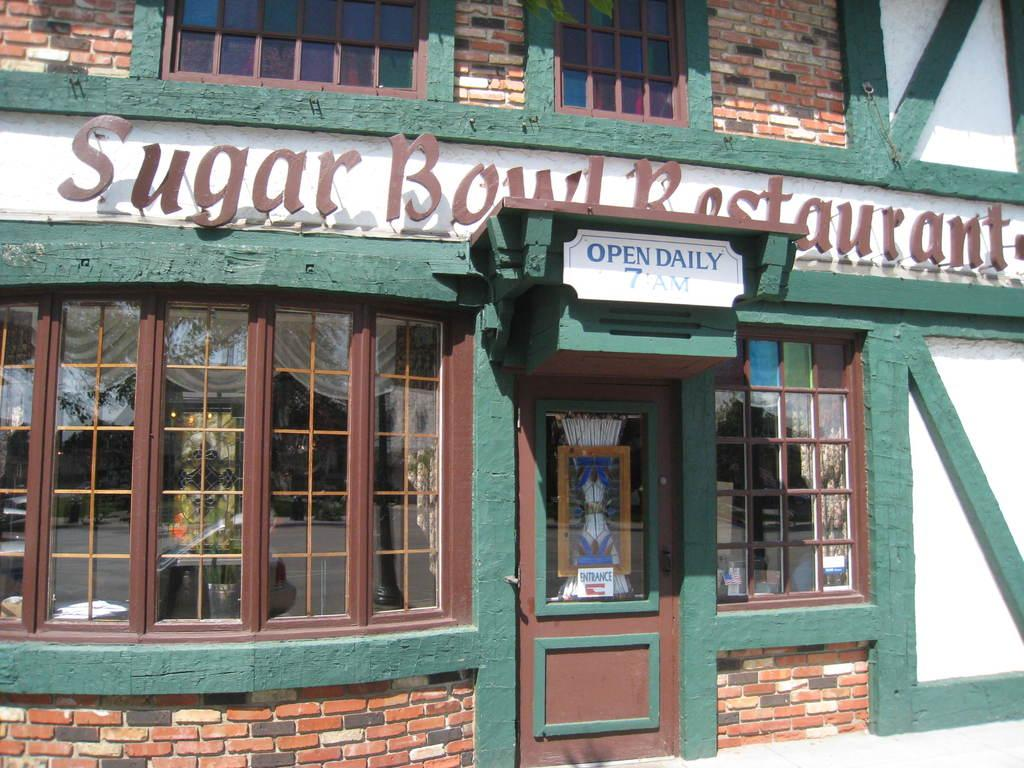What type of structure is visible in the image? There is a building in the image. What is one of the main features of the building? There is a door in the image. What type of material is used for the windows of the building? There are glass windows in the image. What is placed on the walls of the building? There are boards in the image. What can be seen in the glass windows? The glass windows have reflections in the image. What health advice is written on the boards in the image? There is no health advice or caption present on the boards in the image. 